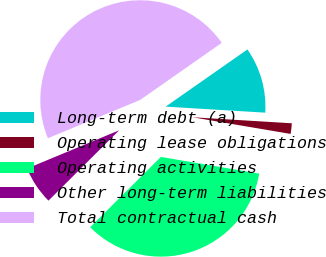Convert chart to OTSL. <chart><loc_0><loc_0><loc_500><loc_500><pie_chart><fcel>Long-term debt (a)<fcel>Operating lease obligations<fcel>Operating activities<fcel>Other long-term liabilities<fcel>Total contractual cash<nl><fcel>10.68%<fcel>1.71%<fcel>34.87%<fcel>6.2%<fcel>46.55%<nl></chart> 